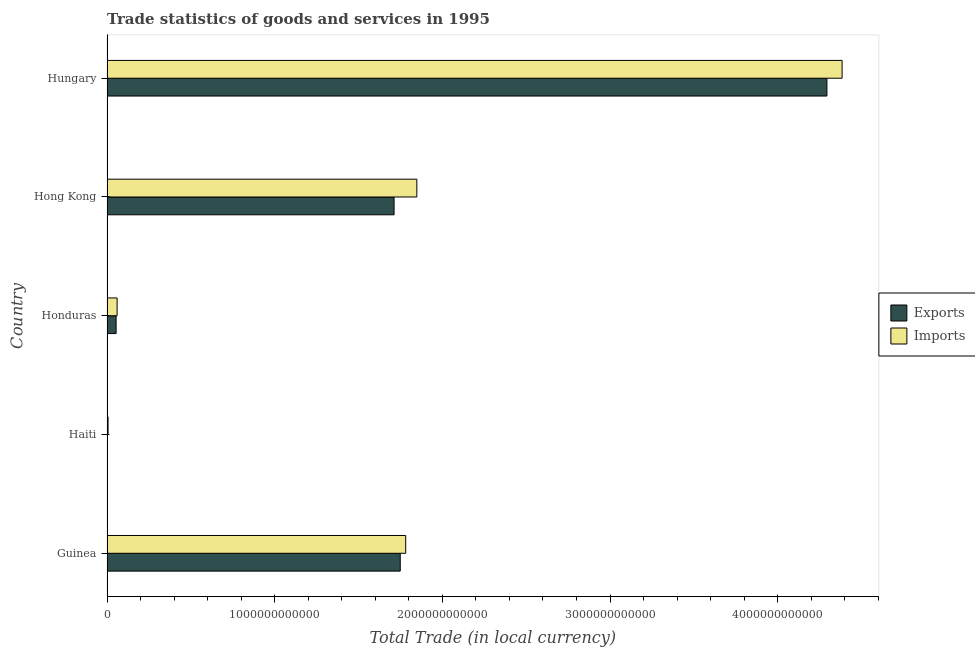Are the number of bars on each tick of the Y-axis equal?
Offer a very short reply. Yes. How many bars are there on the 4th tick from the bottom?
Provide a succinct answer. 2. What is the label of the 3rd group of bars from the top?
Ensure brevity in your answer.  Honduras. What is the export of goods and services in Guinea?
Ensure brevity in your answer.  1.75e+12. Across all countries, what is the maximum export of goods and services?
Keep it short and to the point. 4.29e+12. Across all countries, what is the minimum export of goods and services?
Provide a succinct answer. 1.33e+09. In which country was the imports of goods and services maximum?
Your answer should be compact. Hungary. In which country was the export of goods and services minimum?
Your answer should be very brief. Haiti. What is the total export of goods and services in the graph?
Your answer should be very brief. 7.81e+12. What is the difference between the imports of goods and services in Honduras and that in Hong Kong?
Give a very brief answer. -1.79e+12. What is the difference between the imports of goods and services in Hong Kong and the export of goods and services in Guinea?
Offer a terse response. 9.90e+1. What is the average export of goods and services per country?
Offer a very short reply. 1.56e+12. What is the difference between the imports of goods and services and export of goods and services in Hong Kong?
Offer a terse response. 1.36e+11. In how many countries, is the imports of goods and services greater than 1000000000000 LCU?
Offer a terse response. 3. What is the ratio of the imports of goods and services in Haiti to that in Honduras?
Your answer should be compact. 0.1. Is the imports of goods and services in Guinea less than that in Hong Kong?
Offer a terse response. Yes. Is the difference between the imports of goods and services in Haiti and Hungary greater than the difference between the export of goods and services in Haiti and Hungary?
Give a very brief answer. No. What is the difference between the highest and the second highest export of goods and services?
Offer a terse response. 2.54e+12. What is the difference between the highest and the lowest export of goods and services?
Your answer should be compact. 4.29e+12. Is the sum of the export of goods and services in Hong Kong and Hungary greater than the maximum imports of goods and services across all countries?
Make the answer very short. Yes. What does the 1st bar from the top in Hungary represents?
Offer a terse response. Imports. What does the 1st bar from the bottom in Hungary represents?
Your answer should be very brief. Exports. How many bars are there?
Give a very brief answer. 10. How many countries are there in the graph?
Give a very brief answer. 5. What is the difference between two consecutive major ticks on the X-axis?
Give a very brief answer. 1.00e+12. Are the values on the major ticks of X-axis written in scientific E-notation?
Your answer should be very brief. No. Does the graph contain any zero values?
Give a very brief answer. No. Does the graph contain grids?
Provide a short and direct response. No. How many legend labels are there?
Make the answer very short. 2. How are the legend labels stacked?
Ensure brevity in your answer.  Vertical. What is the title of the graph?
Keep it short and to the point. Trade statistics of goods and services in 1995. What is the label or title of the X-axis?
Your answer should be compact. Total Trade (in local currency). What is the label or title of the Y-axis?
Give a very brief answer. Country. What is the Total Trade (in local currency) in Exports in Guinea?
Offer a very short reply. 1.75e+12. What is the Total Trade (in local currency) of Imports in Guinea?
Offer a terse response. 1.78e+12. What is the Total Trade (in local currency) of Exports in Haiti?
Your answer should be very brief. 1.33e+09. What is the Total Trade (in local currency) of Imports in Haiti?
Provide a succinct answer. 6.34e+09. What is the Total Trade (in local currency) of Exports in Honduras?
Offer a terse response. 5.43e+1. What is the Total Trade (in local currency) in Imports in Honduras?
Ensure brevity in your answer.  6.03e+1. What is the Total Trade (in local currency) in Exports in Hong Kong?
Provide a succinct answer. 1.71e+12. What is the Total Trade (in local currency) in Imports in Hong Kong?
Ensure brevity in your answer.  1.85e+12. What is the Total Trade (in local currency) of Exports in Hungary?
Make the answer very short. 4.29e+12. What is the Total Trade (in local currency) of Imports in Hungary?
Keep it short and to the point. 4.38e+12. Across all countries, what is the maximum Total Trade (in local currency) in Exports?
Ensure brevity in your answer.  4.29e+12. Across all countries, what is the maximum Total Trade (in local currency) in Imports?
Give a very brief answer. 4.38e+12. Across all countries, what is the minimum Total Trade (in local currency) in Exports?
Provide a short and direct response. 1.33e+09. Across all countries, what is the minimum Total Trade (in local currency) in Imports?
Keep it short and to the point. 6.34e+09. What is the total Total Trade (in local currency) in Exports in the graph?
Provide a succinct answer. 7.81e+12. What is the total Total Trade (in local currency) in Imports in the graph?
Make the answer very short. 8.08e+12. What is the difference between the Total Trade (in local currency) in Exports in Guinea and that in Haiti?
Offer a very short reply. 1.75e+12. What is the difference between the Total Trade (in local currency) of Imports in Guinea and that in Haiti?
Your response must be concise. 1.78e+12. What is the difference between the Total Trade (in local currency) of Exports in Guinea and that in Honduras?
Keep it short and to the point. 1.69e+12. What is the difference between the Total Trade (in local currency) in Imports in Guinea and that in Honduras?
Give a very brief answer. 1.72e+12. What is the difference between the Total Trade (in local currency) of Exports in Guinea and that in Hong Kong?
Give a very brief answer. 3.69e+1. What is the difference between the Total Trade (in local currency) of Imports in Guinea and that in Hong Kong?
Offer a terse response. -6.65e+1. What is the difference between the Total Trade (in local currency) in Exports in Guinea and that in Hungary?
Keep it short and to the point. -2.54e+12. What is the difference between the Total Trade (in local currency) in Imports in Guinea and that in Hungary?
Give a very brief answer. -2.60e+12. What is the difference between the Total Trade (in local currency) of Exports in Haiti and that in Honduras?
Make the answer very short. -5.29e+1. What is the difference between the Total Trade (in local currency) in Imports in Haiti and that in Honduras?
Your response must be concise. -5.39e+1. What is the difference between the Total Trade (in local currency) in Exports in Haiti and that in Hong Kong?
Your response must be concise. -1.71e+12. What is the difference between the Total Trade (in local currency) in Imports in Haiti and that in Hong Kong?
Keep it short and to the point. -1.84e+12. What is the difference between the Total Trade (in local currency) of Exports in Haiti and that in Hungary?
Give a very brief answer. -4.29e+12. What is the difference between the Total Trade (in local currency) of Imports in Haiti and that in Hungary?
Your response must be concise. -4.38e+12. What is the difference between the Total Trade (in local currency) in Exports in Honduras and that in Hong Kong?
Your response must be concise. -1.66e+12. What is the difference between the Total Trade (in local currency) of Imports in Honduras and that in Hong Kong?
Give a very brief answer. -1.79e+12. What is the difference between the Total Trade (in local currency) of Exports in Honduras and that in Hungary?
Offer a terse response. -4.24e+12. What is the difference between the Total Trade (in local currency) in Imports in Honduras and that in Hungary?
Make the answer very short. -4.32e+12. What is the difference between the Total Trade (in local currency) of Exports in Hong Kong and that in Hungary?
Provide a short and direct response. -2.58e+12. What is the difference between the Total Trade (in local currency) in Imports in Hong Kong and that in Hungary?
Offer a very short reply. -2.54e+12. What is the difference between the Total Trade (in local currency) of Exports in Guinea and the Total Trade (in local currency) of Imports in Haiti?
Keep it short and to the point. 1.74e+12. What is the difference between the Total Trade (in local currency) of Exports in Guinea and the Total Trade (in local currency) of Imports in Honduras?
Offer a terse response. 1.69e+12. What is the difference between the Total Trade (in local currency) of Exports in Guinea and the Total Trade (in local currency) of Imports in Hong Kong?
Ensure brevity in your answer.  -9.90e+1. What is the difference between the Total Trade (in local currency) of Exports in Guinea and the Total Trade (in local currency) of Imports in Hungary?
Make the answer very short. -2.64e+12. What is the difference between the Total Trade (in local currency) in Exports in Haiti and the Total Trade (in local currency) in Imports in Honduras?
Offer a very short reply. -5.90e+1. What is the difference between the Total Trade (in local currency) of Exports in Haiti and the Total Trade (in local currency) of Imports in Hong Kong?
Your answer should be very brief. -1.85e+12. What is the difference between the Total Trade (in local currency) of Exports in Haiti and the Total Trade (in local currency) of Imports in Hungary?
Keep it short and to the point. -4.38e+12. What is the difference between the Total Trade (in local currency) in Exports in Honduras and the Total Trade (in local currency) in Imports in Hong Kong?
Your answer should be compact. -1.79e+12. What is the difference between the Total Trade (in local currency) in Exports in Honduras and the Total Trade (in local currency) in Imports in Hungary?
Your response must be concise. -4.33e+12. What is the difference between the Total Trade (in local currency) in Exports in Hong Kong and the Total Trade (in local currency) in Imports in Hungary?
Your answer should be very brief. -2.67e+12. What is the average Total Trade (in local currency) of Exports per country?
Your answer should be compact. 1.56e+12. What is the average Total Trade (in local currency) in Imports per country?
Ensure brevity in your answer.  1.62e+12. What is the difference between the Total Trade (in local currency) of Exports and Total Trade (in local currency) of Imports in Guinea?
Your answer should be compact. -3.25e+1. What is the difference between the Total Trade (in local currency) of Exports and Total Trade (in local currency) of Imports in Haiti?
Ensure brevity in your answer.  -5.02e+09. What is the difference between the Total Trade (in local currency) in Exports and Total Trade (in local currency) in Imports in Honduras?
Offer a very short reply. -6.02e+09. What is the difference between the Total Trade (in local currency) in Exports and Total Trade (in local currency) in Imports in Hong Kong?
Your answer should be very brief. -1.36e+11. What is the difference between the Total Trade (in local currency) in Exports and Total Trade (in local currency) in Imports in Hungary?
Offer a very short reply. -9.05e+1. What is the ratio of the Total Trade (in local currency) of Exports in Guinea to that in Haiti?
Provide a succinct answer. 1318.95. What is the ratio of the Total Trade (in local currency) in Imports in Guinea to that in Haiti?
Your answer should be very brief. 280.76. What is the ratio of the Total Trade (in local currency) in Exports in Guinea to that in Honduras?
Provide a short and direct response. 32.22. What is the ratio of the Total Trade (in local currency) of Imports in Guinea to that in Honduras?
Give a very brief answer. 29.55. What is the ratio of the Total Trade (in local currency) in Exports in Guinea to that in Hong Kong?
Give a very brief answer. 1.02. What is the ratio of the Total Trade (in local currency) of Exports in Guinea to that in Hungary?
Your answer should be compact. 0.41. What is the ratio of the Total Trade (in local currency) of Imports in Guinea to that in Hungary?
Your answer should be very brief. 0.41. What is the ratio of the Total Trade (in local currency) in Exports in Haiti to that in Honduras?
Your response must be concise. 0.02. What is the ratio of the Total Trade (in local currency) of Imports in Haiti to that in Honduras?
Provide a succinct answer. 0.11. What is the ratio of the Total Trade (in local currency) of Exports in Haiti to that in Hong Kong?
Your response must be concise. 0. What is the ratio of the Total Trade (in local currency) in Imports in Haiti to that in Hong Kong?
Provide a short and direct response. 0. What is the ratio of the Total Trade (in local currency) of Imports in Haiti to that in Hungary?
Provide a short and direct response. 0. What is the ratio of the Total Trade (in local currency) in Exports in Honduras to that in Hong Kong?
Give a very brief answer. 0.03. What is the ratio of the Total Trade (in local currency) in Imports in Honduras to that in Hong Kong?
Make the answer very short. 0.03. What is the ratio of the Total Trade (in local currency) in Exports in Honduras to that in Hungary?
Your response must be concise. 0.01. What is the ratio of the Total Trade (in local currency) of Imports in Honduras to that in Hungary?
Your response must be concise. 0.01. What is the ratio of the Total Trade (in local currency) of Exports in Hong Kong to that in Hungary?
Provide a short and direct response. 0.4. What is the ratio of the Total Trade (in local currency) of Imports in Hong Kong to that in Hungary?
Provide a succinct answer. 0.42. What is the difference between the highest and the second highest Total Trade (in local currency) in Exports?
Offer a terse response. 2.54e+12. What is the difference between the highest and the second highest Total Trade (in local currency) of Imports?
Your answer should be very brief. 2.54e+12. What is the difference between the highest and the lowest Total Trade (in local currency) in Exports?
Your response must be concise. 4.29e+12. What is the difference between the highest and the lowest Total Trade (in local currency) of Imports?
Offer a terse response. 4.38e+12. 